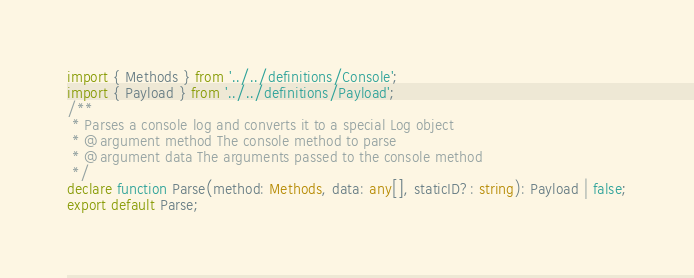Convert code to text. <code><loc_0><loc_0><loc_500><loc_500><_TypeScript_>import { Methods } from '../../definitions/Console';
import { Payload } from '../../definitions/Payload';
/**
 * Parses a console log and converts it to a special Log object
 * @argument method The console method to parse
 * @argument data The arguments passed to the console method
 */
declare function Parse(method: Methods, data: any[], staticID?: string): Payload | false;
export default Parse;
</code> 